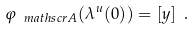<formula> <loc_0><loc_0><loc_500><loc_500>\varphi _ { \ m a t h s c r { A } } ( \lambda ^ { u } ( 0 ) ) = [ y ] \ .</formula> 